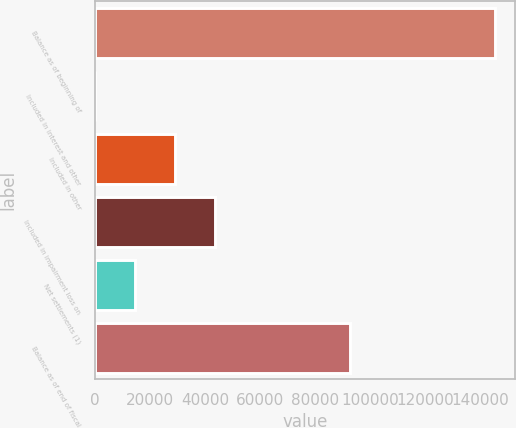<chart> <loc_0><loc_0><loc_500><loc_500><bar_chart><fcel>Balance as of beginning of<fcel>Included in interest and other<fcel>Included in other<fcel>Included in impairment loss on<fcel>Net settlements (1)<fcel>Balance as of end of fiscal<nl><fcel>145388<fcel>170<fcel>29213.6<fcel>43735.4<fcel>14691.8<fcel>92736<nl></chart> 